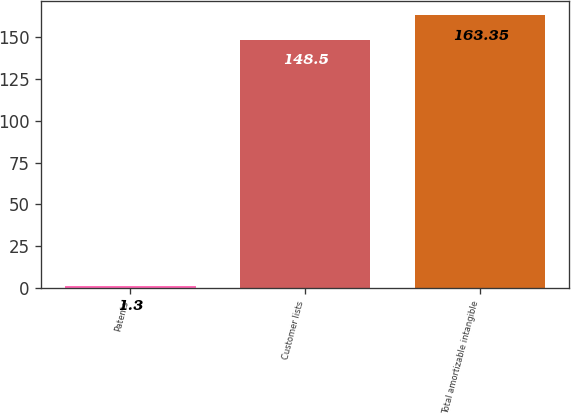Convert chart. <chart><loc_0><loc_0><loc_500><loc_500><bar_chart><fcel>Patents<fcel>Customer lists<fcel>Total amortizable intangible<nl><fcel>1.3<fcel>148.5<fcel>163.35<nl></chart> 